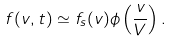Convert formula to latex. <formula><loc_0><loc_0><loc_500><loc_500>f ( v , t ) \simeq f _ { s } ( v ) \phi \left ( \frac { v } { V } \right ) .</formula> 